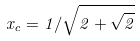<formula> <loc_0><loc_0><loc_500><loc_500>x _ { c } = 1 / \sqrt { 2 + \sqrt { 2 } }</formula> 